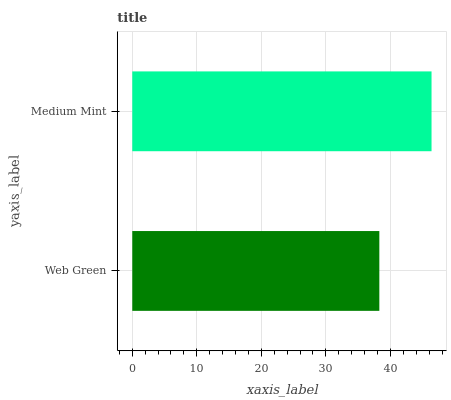Is Web Green the minimum?
Answer yes or no. Yes. Is Medium Mint the maximum?
Answer yes or no. Yes. Is Medium Mint the minimum?
Answer yes or no. No. Is Medium Mint greater than Web Green?
Answer yes or no. Yes. Is Web Green less than Medium Mint?
Answer yes or no. Yes. Is Web Green greater than Medium Mint?
Answer yes or no. No. Is Medium Mint less than Web Green?
Answer yes or no. No. Is Medium Mint the high median?
Answer yes or no. Yes. Is Web Green the low median?
Answer yes or no. Yes. Is Web Green the high median?
Answer yes or no. No. Is Medium Mint the low median?
Answer yes or no. No. 